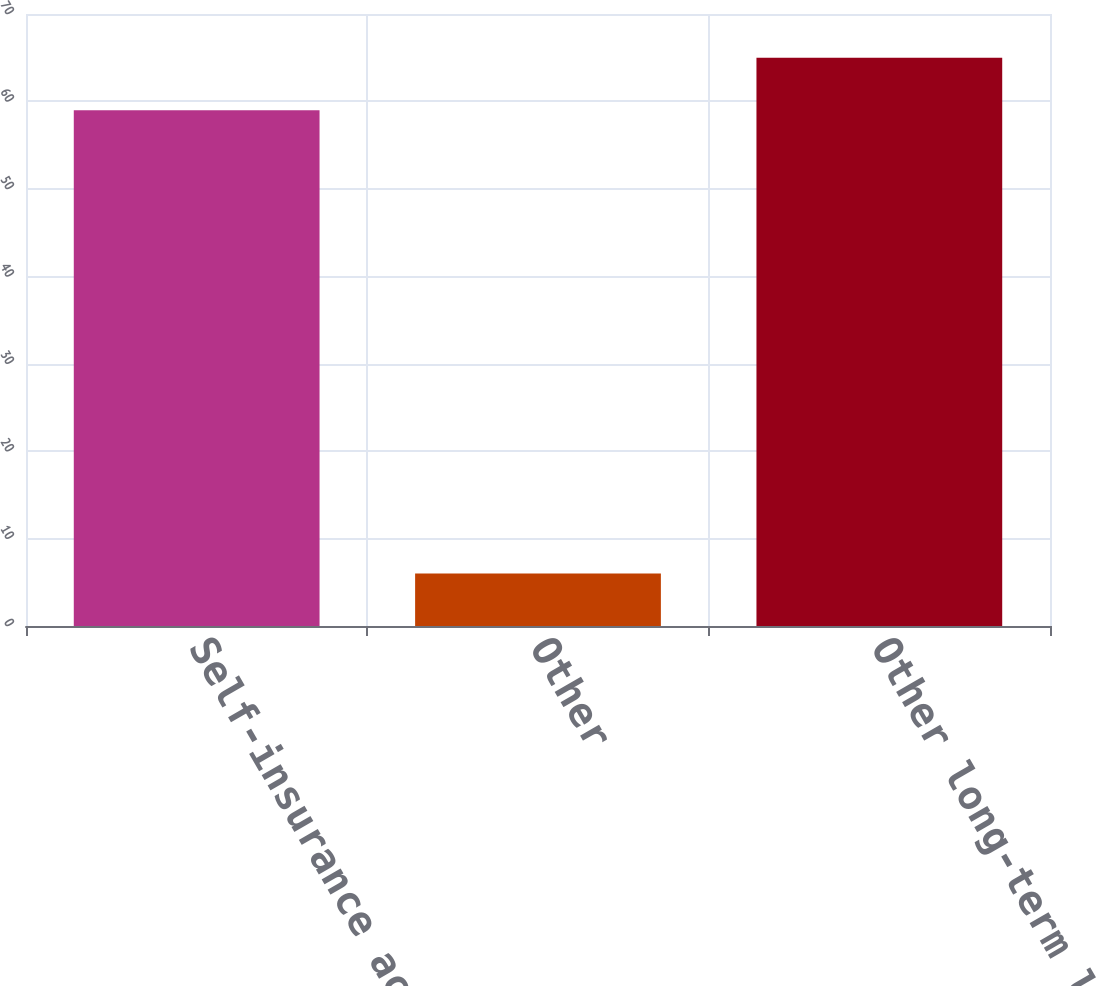Convert chart. <chart><loc_0><loc_0><loc_500><loc_500><bar_chart><fcel>Self-insurance accruals<fcel>Other<fcel>Other long-term liabilities<nl><fcel>59<fcel>6<fcel>65<nl></chart> 